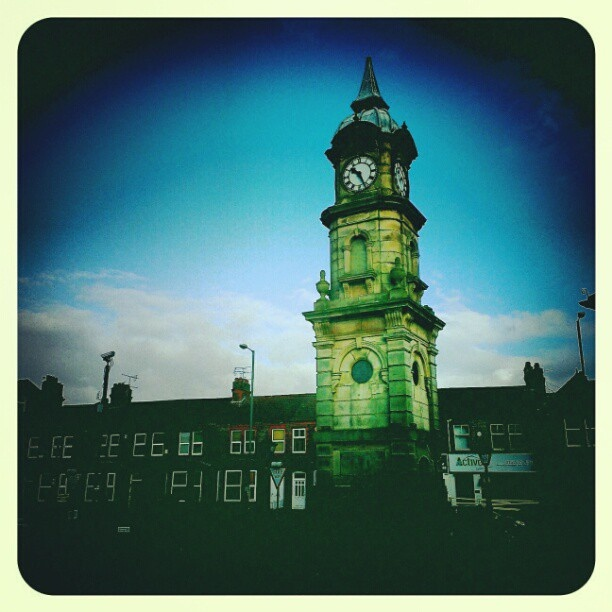Describe the objects in this image and their specific colors. I can see clock in lightyellow, darkgray, teal, black, and turquoise tones and clock in lightyellow, teal, black, and darkgray tones in this image. 